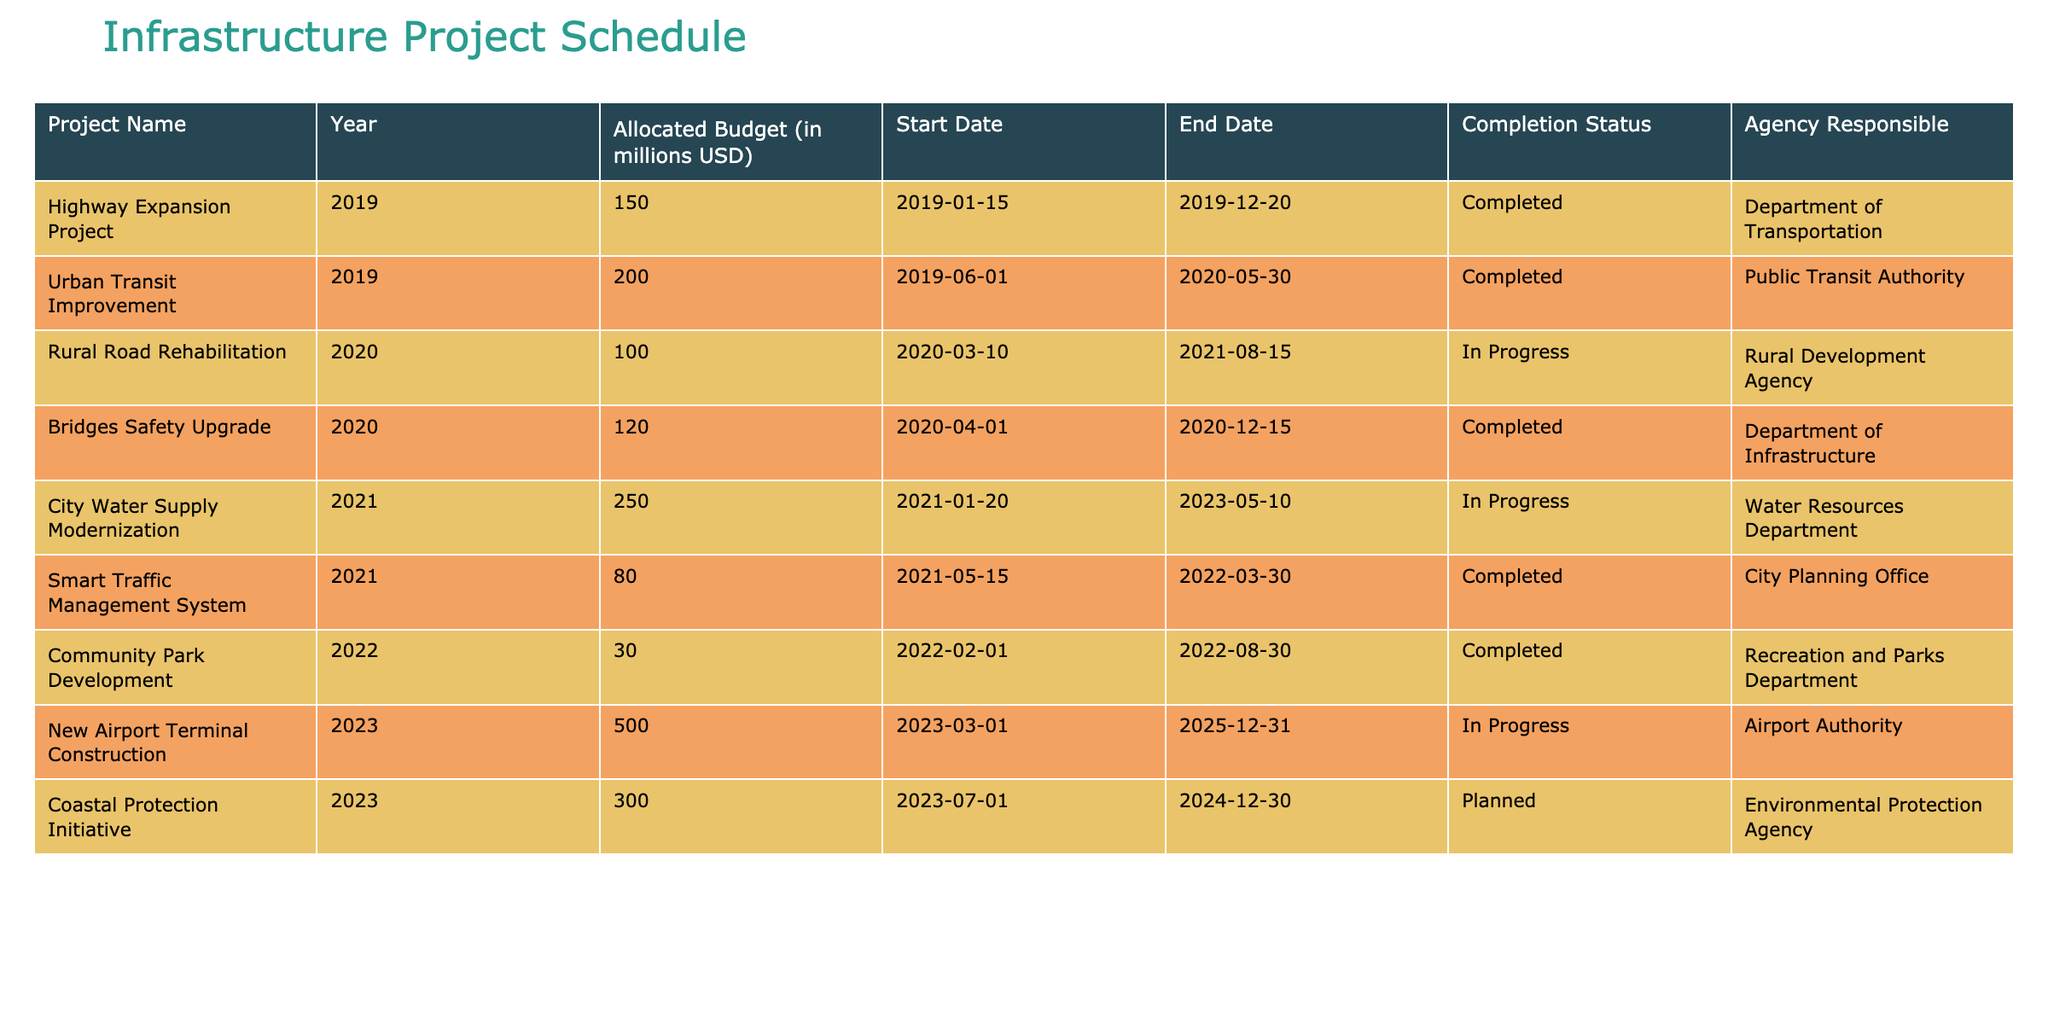What is the total allocated budget for projects completed in 2019? In 2019, there are two completed projects: Highway Expansion Project with an allocated budget of 150 million USD and Urban Transit Improvement with 200 million USD. By summing these amounts, the total allocated budget is 150 + 200 = 350 million USD.
Answer: 350 million USD Which project has the highest allocated budget? By examining the table, the New Airport Terminal Construction project in 2023 has the highest allocated budget of 500 million USD.
Answer: 500 million USD Is the City Water Supply Modernization project completed? The table indicates that the City Water Supply Modernization project, which started in 2021 and is expected to end in 2023, is currently marked as "In Progress." Therefore, it is not completed.
Answer: No How many projects are currently in progress? The table lists three projects with the status "In Progress": Rural Road Rehabilitation (2020), City Water Supply Modernization (2021), and New Airport Terminal Construction (2023). Thus, there are a total of 3 projects in progress.
Answer: 3 What is the average allocated budget for all completed projects? We first identify the completed projects and their allocated budgets: Highway Expansion Project (150 million USD), Urban Transit Improvement (200 million USD), Bridges Safety Upgrade (120 million USD), Smart Traffic Management System (80 million USD), Community Park Development (30 million USD). There are 5 completed projects, so we sum the budgets: 150 + 200 + 120 + 80 + 30 = 580 million USD. The average is 580/5 = 116 million USD.
Answer: 116 million USD What percentage of the total budget is allocated to the Coastal Protection Initiative? The Coastal Protection Initiative is planned for 300 million USD. The total allocated budget across all listed projects is 150 + 200 + 100 + 120 + 250 + 80 + 30 + 500 + 300 = 1730 million USD. To find the percentage allocated to the Coastal Protection Initiative, we calculate (300 / 1730) * 100 ≈ 17.3%.
Answer: Approximately 17.3% Are there any projects that have an allocated budget less than 50 million USD? By reviewing the table, the only project that falls below 50 million USD is the Community Park Development, which has an allocated budget of 30 million USD. Therefore, there is at least one project with an allocation less than 50 million USD.
Answer: Yes Which agency is responsible for the Urban Transit Improvement project? According to the table, the Urban Transit Improvement project is under the jurisdiction of the Public Transit Authority.
Answer: Public Transit Authority 